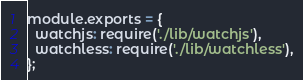Convert code to text. <code><loc_0><loc_0><loc_500><loc_500><_JavaScript_>module.exports = {
  watchjs: require('./lib/watchjs'),
  watchless: require('./lib/watchless'),
};
</code> 